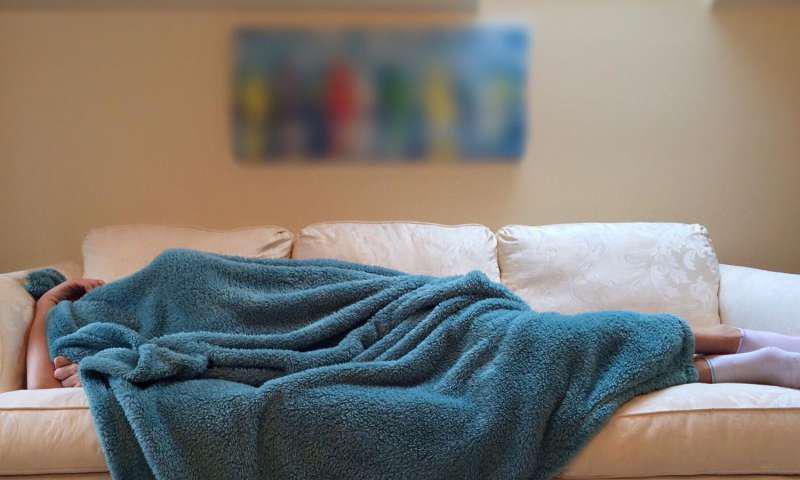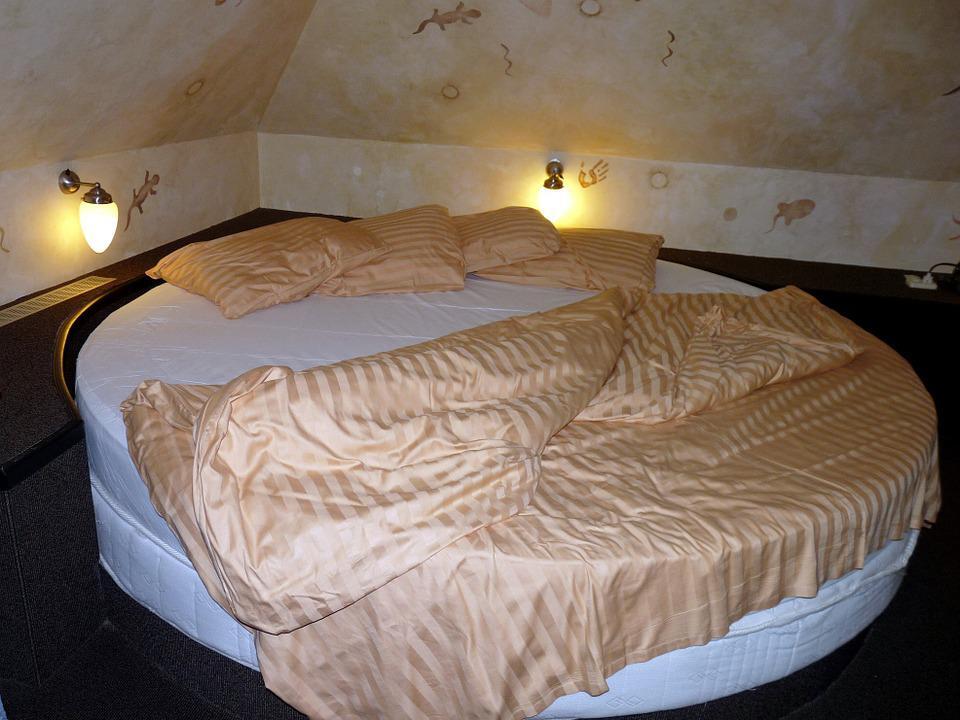The first image is the image on the left, the second image is the image on the right. Considering the images on both sides, is "An image shows a bed that features a round design element." valid? Answer yes or no. Yes. 